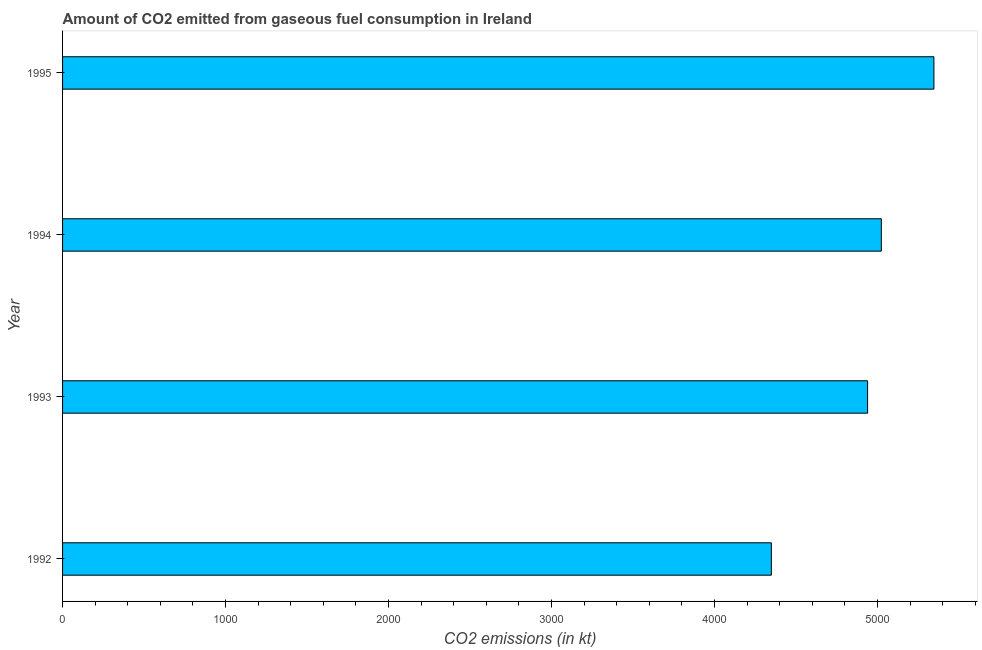Does the graph contain any zero values?
Provide a succinct answer. No. What is the title of the graph?
Provide a succinct answer. Amount of CO2 emitted from gaseous fuel consumption in Ireland. What is the label or title of the X-axis?
Offer a terse response. CO2 emissions (in kt). What is the label or title of the Y-axis?
Make the answer very short. Year. What is the co2 emissions from gaseous fuel consumption in 1994?
Make the answer very short. 5023.79. Across all years, what is the maximum co2 emissions from gaseous fuel consumption?
Provide a succinct answer. 5346.49. Across all years, what is the minimum co2 emissions from gaseous fuel consumption?
Your answer should be compact. 4349.06. In which year was the co2 emissions from gaseous fuel consumption maximum?
Offer a terse response. 1995. In which year was the co2 emissions from gaseous fuel consumption minimum?
Provide a succinct answer. 1992. What is the sum of the co2 emissions from gaseous fuel consumption?
Your answer should be compact. 1.97e+04. What is the difference between the co2 emissions from gaseous fuel consumption in 1994 and 1995?
Provide a succinct answer. -322.7. What is the average co2 emissions from gaseous fuel consumption per year?
Your answer should be compact. 4914.7. What is the median co2 emissions from gaseous fuel consumption?
Your answer should be compact. 4981.62. In how many years, is the co2 emissions from gaseous fuel consumption greater than 4000 kt?
Give a very brief answer. 4. What is the ratio of the co2 emissions from gaseous fuel consumption in 1992 to that in 1994?
Make the answer very short. 0.87. What is the difference between the highest and the second highest co2 emissions from gaseous fuel consumption?
Ensure brevity in your answer.  322.7. Is the sum of the co2 emissions from gaseous fuel consumption in 1994 and 1995 greater than the maximum co2 emissions from gaseous fuel consumption across all years?
Offer a terse response. Yes. What is the difference between the highest and the lowest co2 emissions from gaseous fuel consumption?
Your response must be concise. 997.42. In how many years, is the co2 emissions from gaseous fuel consumption greater than the average co2 emissions from gaseous fuel consumption taken over all years?
Your answer should be compact. 3. Are the values on the major ticks of X-axis written in scientific E-notation?
Your answer should be compact. No. What is the CO2 emissions (in kt) of 1992?
Offer a terse response. 4349.06. What is the CO2 emissions (in kt) in 1993?
Provide a succinct answer. 4939.45. What is the CO2 emissions (in kt) of 1994?
Your answer should be compact. 5023.79. What is the CO2 emissions (in kt) of 1995?
Your answer should be very brief. 5346.49. What is the difference between the CO2 emissions (in kt) in 1992 and 1993?
Your answer should be compact. -590.39. What is the difference between the CO2 emissions (in kt) in 1992 and 1994?
Your response must be concise. -674.73. What is the difference between the CO2 emissions (in kt) in 1992 and 1995?
Your answer should be very brief. -997.42. What is the difference between the CO2 emissions (in kt) in 1993 and 1994?
Your response must be concise. -84.34. What is the difference between the CO2 emissions (in kt) in 1993 and 1995?
Give a very brief answer. -407.04. What is the difference between the CO2 emissions (in kt) in 1994 and 1995?
Your answer should be compact. -322.7. What is the ratio of the CO2 emissions (in kt) in 1992 to that in 1993?
Offer a terse response. 0.88. What is the ratio of the CO2 emissions (in kt) in 1992 to that in 1994?
Your response must be concise. 0.87. What is the ratio of the CO2 emissions (in kt) in 1992 to that in 1995?
Give a very brief answer. 0.81. What is the ratio of the CO2 emissions (in kt) in 1993 to that in 1994?
Offer a terse response. 0.98. What is the ratio of the CO2 emissions (in kt) in 1993 to that in 1995?
Ensure brevity in your answer.  0.92. What is the ratio of the CO2 emissions (in kt) in 1994 to that in 1995?
Ensure brevity in your answer.  0.94. 